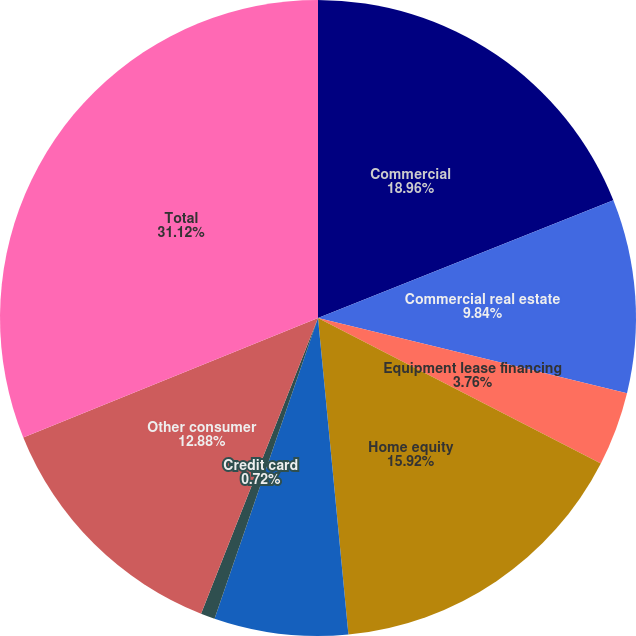<chart> <loc_0><loc_0><loc_500><loc_500><pie_chart><fcel>Commercial<fcel>Commercial real estate<fcel>Equipment lease financing<fcel>Home equity<fcel>Residential real estate<fcel>Credit card<fcel>Other consumer<fcel>Total<nl><fcel>18.96%<fcel>9.84%<fcel>3.76%<fcel>15.92%<fcel>6.8%<fcel>0.72%<fcel>12.88%<fcel>31.13%<nl></chart> 